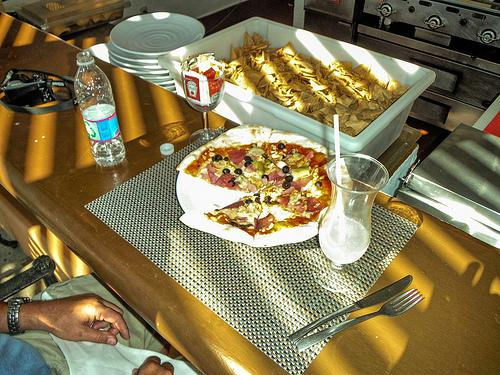Describe something unique about the pizza in the image. The pizza is missing a slice, and it has olives and peppers as toppings. Identify the type of beverage container in the image, as well as its contents. A clear plastic water bottle with a blue label is nearly empty. What type of eating utensils are present in the image, and describe their appearance. There are silver fork and knife eating utensils with a metallic gray color. Describe a particular topping found on the pizza in the image. There is pink ham as a topping on the pizza. Provide a brief description of the main dish in the image. A round pizza with various toppings is missing a slice, revealing its sauce and cheese. Describe the time-telling accessory in the image and on whom it is found. A man's wrist is adorned with a silver watch. Identify an item in the image that has a fun, tropical vibe. A tall tiki-style cup is seen in the picture. What untraditional items are found inside a glass in the image? A glass is filled with various sauce packets, including ketchup. Mention an interesting way condiments are being stored in the image. A wine glass is filled with ketchup packets. Give a short description of the table setting in the image. The table is set with a pizza, utensils, a water bottle, a tiki cup, and a wine glass filled with ketchup packets. 